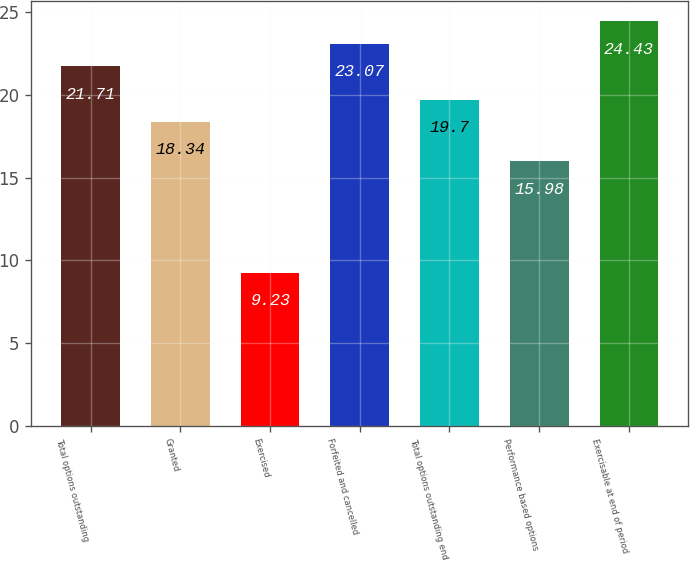Convert chart. <chart><loc_0><loc_0><loc_500><loc_500><bar_chart><fcel>Total options outstanding<fcel>Granted<fcel>Exercised<fcel>Forfeited and cancelled<fcel>Total options outstanding end<fcel>Performance based options<fcel>Exercisable at end of period<nl><fcel>21.71<fcel>18.34<fcel>9.23<fcel>23.07<fcel>19.7<fcel>15.98<fcel>24.43<nl></chart> 